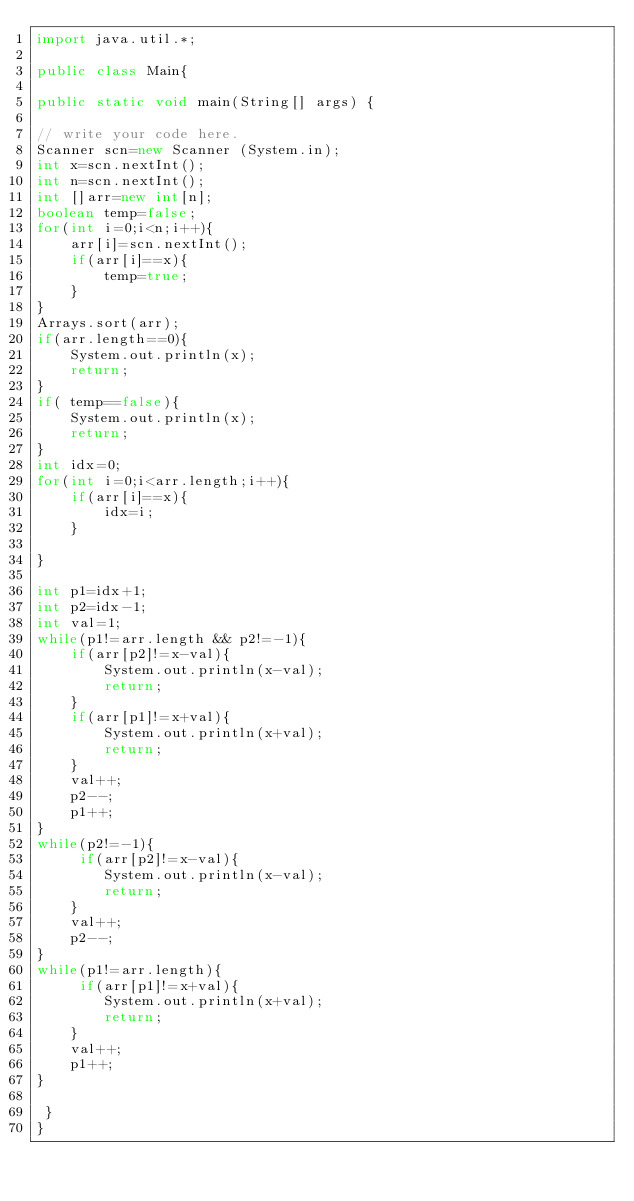<code> <loc_0><loc_0><loc_500><loc_500><_Java_>import java.util.*;

public class Main{

public static void main(String[] args) {

// write your code here.
Scanner scn=new Scanner (System.in);
int x=scn.nextInt();
int n=scn.nextInt();
int []arr=new int[n];
boolean temp=false;
for(int i=0;i<n;i++){
    arr[i]=scn.nextInt();
    if(arr[i]==x){
        temp=true;
    }
}
Arrays.sort(arr);
if(arr.length==0){
    System.out.println(x);
    return;
}
if( temp==false){
    System.out.println(x);
    return;
}
int idx=0;
for(int i=0;i<arr.length;i++){
    if(arr[i]==x){
        idx=i;
    }
    
}

int p1=idx+1;
int p2=idx-1;
int val=1;
while(p1!=arr.length && p2!=-1){
    if(arr[p2]!=x-val){
        System.out.println(x-val);
        return;
    }
    if(arr[p1]!=x+val){
        System.out.println(x+val);
        return;
    }
    val++;
    p2--;
    p1++;
}
while(p2!=-1){
     if(arr[p2]!=x-val){
        System.out.println(x-val);
        return;
    }
    val++;
    p2--;
}
while(p1!=arr.length){
     if(arr[p1]!=x+val){
        System.out.println(x+val);
        return;
    }
    val++;
    p1++;
}

 }
}</code> 